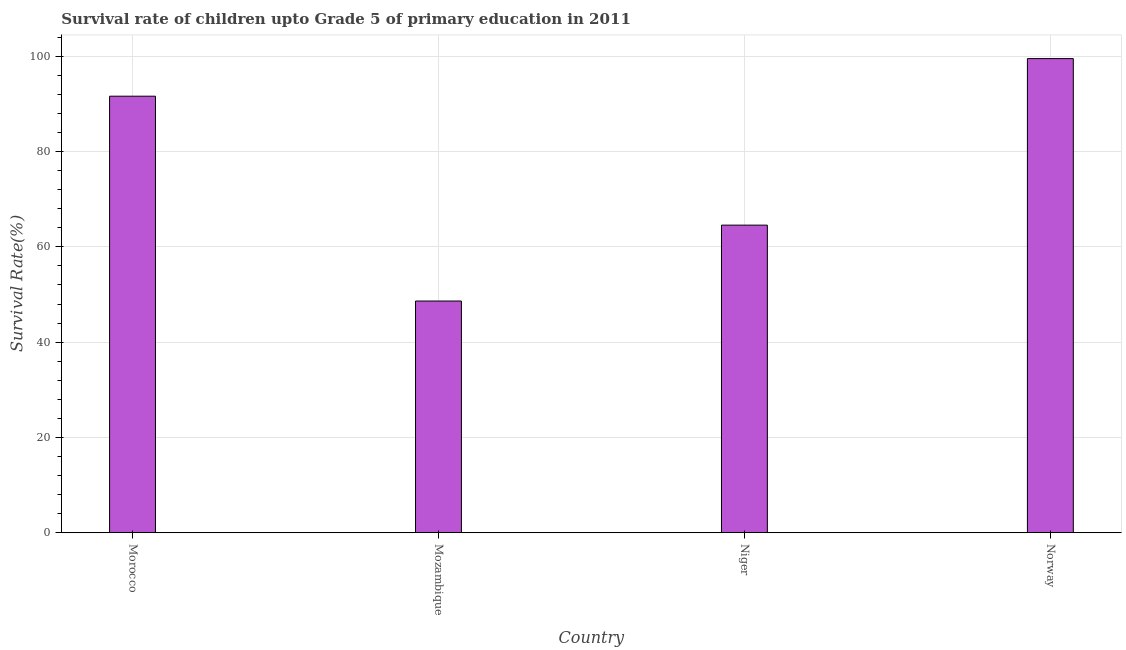Does the graph contain any zero values?
Your response must be concise. No. Does the graph contain grids?
Keep it short and to the point. Yes. What is the title of the graph?
Give a very brief answer. Survival rate of children upto Grade 5 of primary education in 2011 . What is the label or title of the X-axis?
Your response must be concise. Country. What is the label or title of the Y-axis?
Make the answer very short. Survival Rate(%). What is the survival rate in Niger?
Give a very brief answer. 64.56. Across all countries, what is the maximum survival rate?
Make the answer very short. 99.52. Across all countries, what is the minimum survival rate?
Offer a very short reply. 48.63. In which country was the survival rate minimum?
Provide a short and direct response. Mozambique. What is the sum of the survival rate?
Your answer should be compact. 304.33. What is the difference between the survival rate in Mozambique and Niger?
Your answer should be compact. -15.93. What is the average survival rate per country?
Your response must be concise. 76.08. What is the median survival rate?
Make the answer very short. 78.09. What is the ratio of the survival rate in Morocco to that in Norway?
Provide a short and direct response. 0.92. Is the difference between the survival rate in Mozambique and Niger greater than the difference between any two countries?
Give a very brief answer. No. What is the difference between the highest and the second highest survival rate?
Make the answer very short. 7.9. Is the sum of the survival rate in Niger and Norway greater than the maximum survival rate across all countries?
Provide a succinct answer. Yes. What is the difference between the highest and the lowest survival rate?
Provide a succinct answer. 50.89. Are all the bars in the graph horizontal?
Your answer should be very brief. No. How many countries are there in the graph?
Provide a short and direct response. 4. Are the values on the major ticks of Y-axis written in scientific E-notation?
Your answer should be very brief. No. What is the Survival Rate(%) in Morocco?
Make the answer very short. 91.62. What is the Survival Rate(%) in Mozambique?
Provide a succinct answer. 48.63. What is the Survival Rate(%) in Niger?
Keep it short and to the point. 64.56. What is the Survival Rate(%) in Norway?
Keep it short and to the point. 99.52. What is the difference between the Survival Rate(%) in Morocco and Mozambique?
Ensure brevity in your answer.  42.99. What is the difference between the Survival Rate(%) in Morocco and Niger?
Make the answer very short. 27.06. What is the difference between the Survival Rate(%) in Morocco and Norway?
Provide a short and direct response. -7.9. What is the difference between the Survival Rate(%) in Mozambique and Niger?
Offer a terse response. -15.93. What is the difference between the Survival Rate(%) in Mozambique and Norway?
Make the answer very short. -50.89. What is the difference between the Survival Rate(%) in Niger and Norway?
Keep it short and to the point. -34.96. What is the ratio of the Survival Rate(%) in Morocco to that in Mozambique?
Make the answer very short. 1.88. What is the ratio of the Survival Rate(%) in Morocco to that in Niger?
Your response must be concise. 1.42. What is the ratio of the Survival Rate(%) in Morocco to that in Norway?
Offer a terse response. 0.92. What is the ratio of the Survival Rate(%) in Mozambique to that in Niger?
Your response must be concise. 0.75. What is the ratio of the Survival Rate(%) in Mozambique to that in Norway?
Give a very brief answer. 0.49. What is the ratio of the Survival Rate(%) in Niger to that in Norway?
Ensure brevity in your answer.  0.65. 